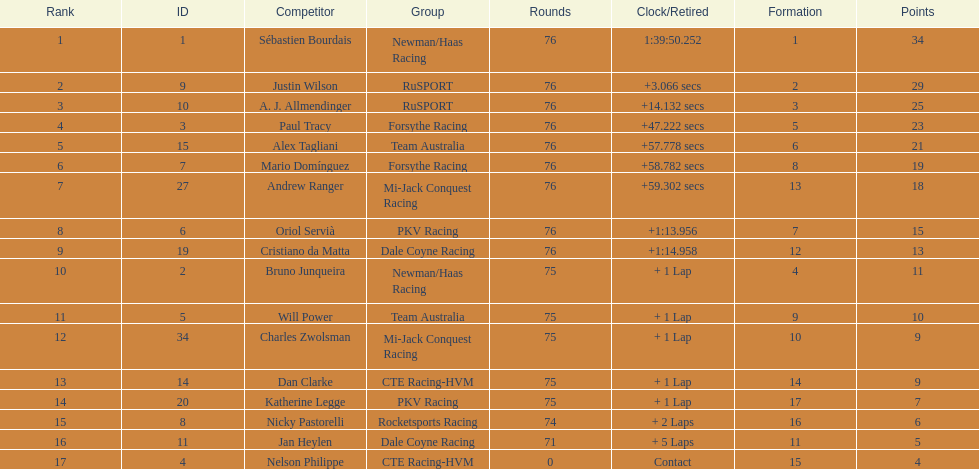How many drivers were competing for brazil? 2. 